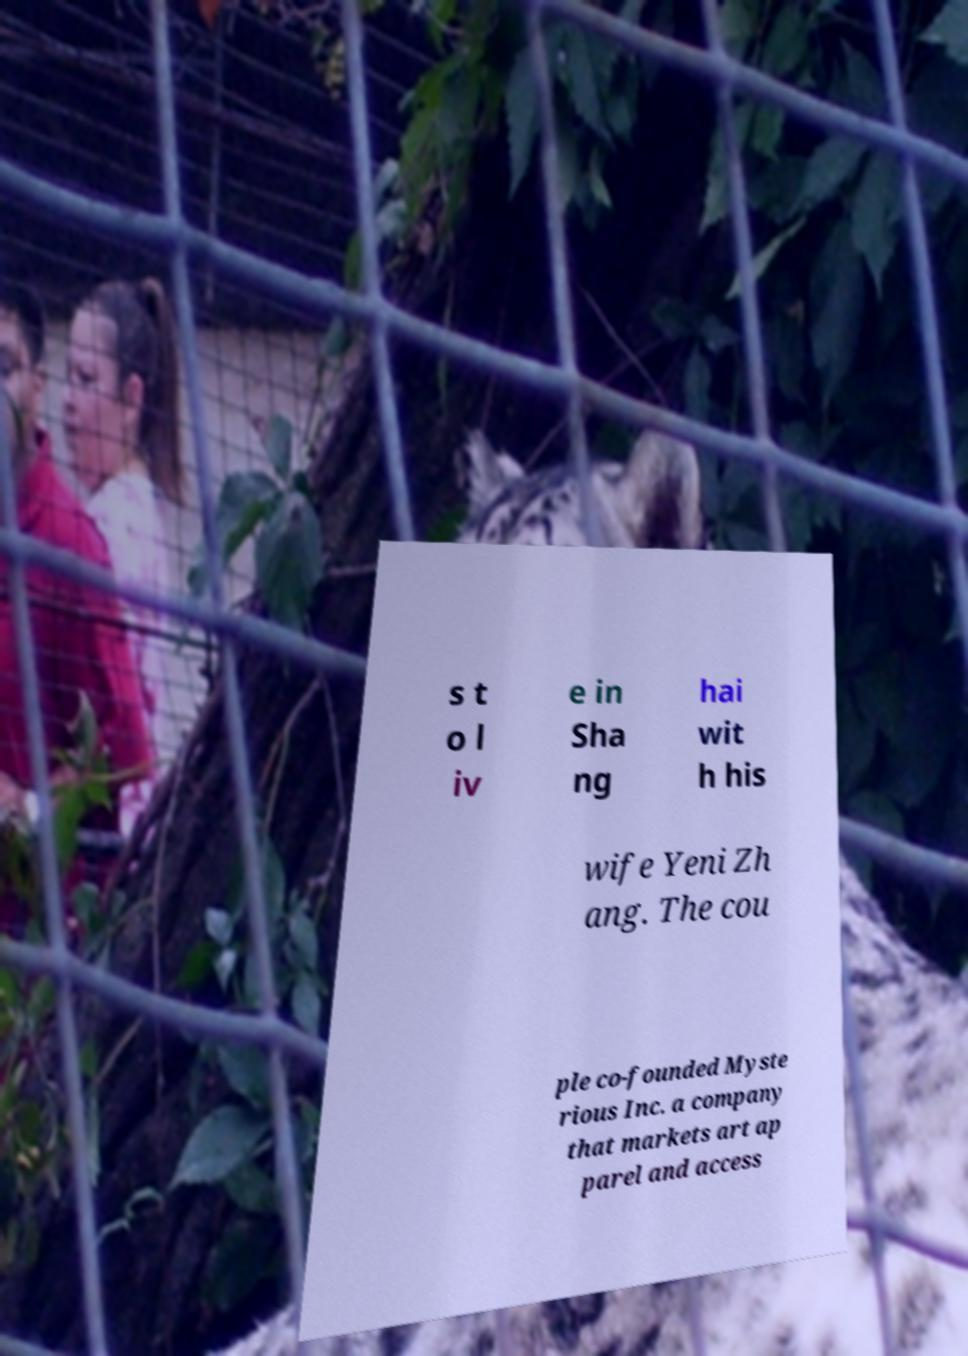For documentation purposes, I need the text within this image transcribed. Could you provide that? s t o l iv e in Sha ng hai wit h his wife Yeni Zh ang. The cou ple co-founded Myste rious Inc. a company that markets art ap parel and access 